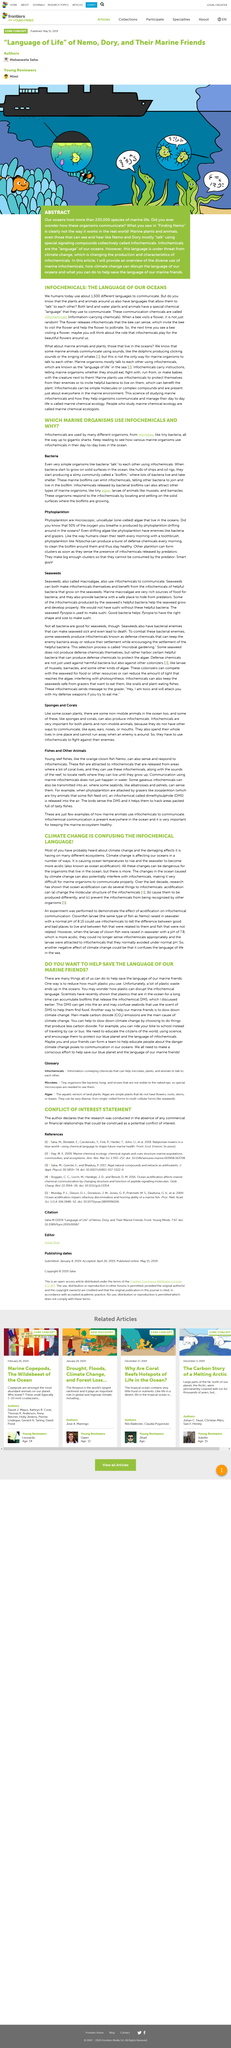Draw attention to some important aspects in this diagram. The answer is yes, clownfish require a Ph level above 8 in order to survive. Seabirds rely on the scent of DMS infochemicals to locate food in the ocean. Marine chemical ecologists are individuals who specialize in the study of the chemical interactions that occur within marine environments. This article is about infochemicals and their importance in our daily lives. Infochemical language refers to chemical substances that facilitate communication among microorganisms, plants, and animals. These chemicals convey information that enables different organisms to interact with each other in a coordinated manner, thereby promoting survival and propagation. 